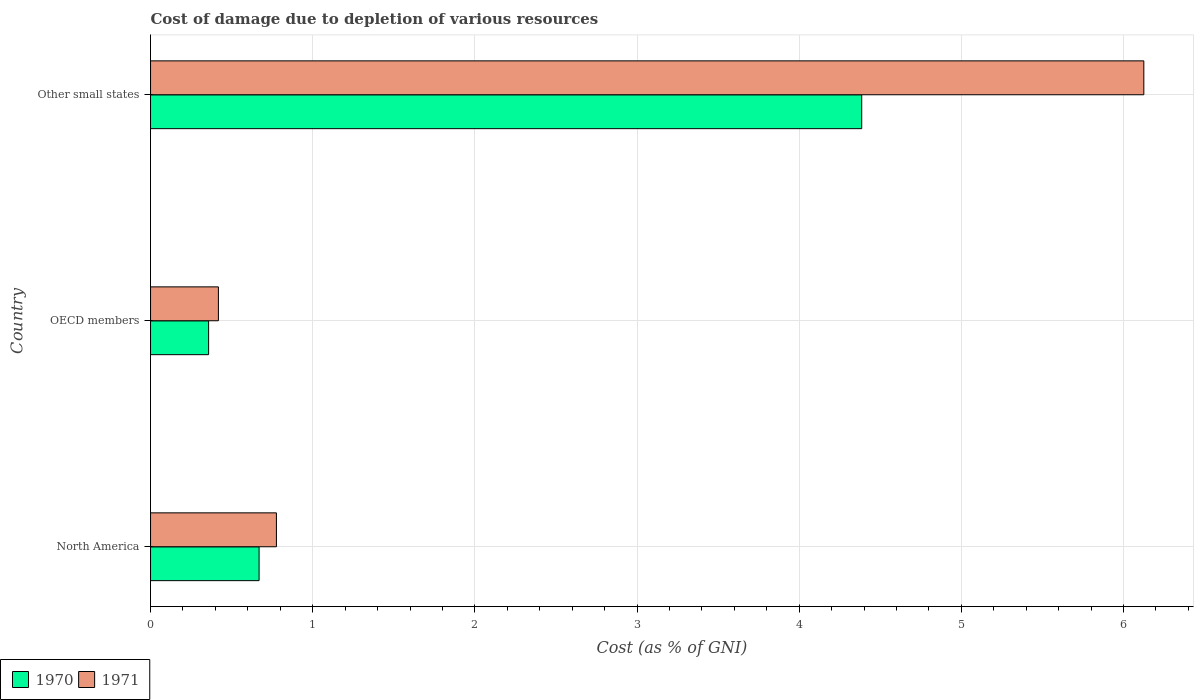How many different coloured bars are there?
Provide a succinct answer. 2. How many groups of bars are there?
Offer a very short reply. 3. Are the number of bars on each tick of the Y-axis equal?
Provide a short and direct response. Yes. How many bars are there on the 1st tick from the top?
Provide a succinct answer. 2. In how many cases, is the number of bars for a given country not equal to the number of legend labels?
Your response must be concise. 0. What is the cost of damage caused due to the depletion of various resources in 1970 in OECD members?
Give a very brief answer. 0.36. Across all countries, what is the maximum cost of damage caused due to the depletion of various resources in 1971?
Give a very brief answer. 6.13. Across all countries, what is the minimum cost of damage caused due to the depletion of various resources in 1971?
Make the answer very short. 0.42. In which country was the cost of damage caused due to the depletion of various resources in 1970 maximum?
Keep it short and to the point. Other small states. In which country was the cost of damage caused due to the depletion of various resources in 1971 minimum?
Provide a succinct answer. OECD members. What is the total cost of damage caused due to the depletion of various resources in 1971 in the graph?
Keep it short and to the point. 7.32. What is the difference between the cost of damage caused due to the depletion of various resources in 1970 in North America and that in OECD members?
Provide a short and direct response. 0.31. What is the difference between the cost of damage caused due to the depletion of various resources in 1971 in OECD members and the cost of damage caused due to the depletion of various resources in 1970 in Other small states?
Your response must be concise. -3.97. What is the average cost of damage caused due to the depletion of various resources in 1970 per country?
Offer a terse response. 1.8. What is the difference between the cost of damage caused due to the depletion of various resources in 1971 and cost of damage caused due to the depletion of various resources in 1970 in Other small states?
Your response must be concise. 1.74. In how many countries, is the cost of damage caused due to the depletion of various resources in 1971 greater than 6.2 %?
Provide a succinct answer. 0. What is the ratio of the cost of damage caused due to the depletion of various resources in 1970 in North America to that in Other small states?
Your response must be concise. 0.15. Is the cost of damage caused due to the depletion of various resources in 1971 in North America less than that in OECD members?
Provide a short and direct response. No. Is the difference between the cost of damage caused due to the depletion of various resources in 1971 in North America and OECD members greater than the difference between the cost of damage caused due to the depletion of various resources in 1970 in North America and OECD members?
Make the answer very short. Yes. What is the difference between the highest and the second highest cost of damage caused due to the depletion of various resources in 1971?
Your response must be concise. 5.35. What is the difference between the highest and the lowest cost of damage caused due to the depletion of various resources in 1971?
Ensure brevity in your answer.  5.71. In how many countries, is the cost of damage caused due to the depletion of various resources in 1971 greater than the average cost of damage caused due to the depletion of various resources in 1971 taken over all countries?
Provide a short and direct response. 1. What does the 2nd bar from the bottom in North America represents?
Ensure brevity in your answer.  1971. How many bars are there?
Make the answer very short. 6. How many countries are there in the graph?
Make the answer very short. 3. Are the values on the major ticks of X-axis written in scientific E-notation?
Provide a succinct answer. No. Does the graph contain grids?
Your answer should be very brief. Yes. How are the legend labels stacked?
Your answer should be compact. Horizontal. What is the title of the graph?
Keep it short and to the point. Cost of damage due to depletion of various resources. What is the label or title of the X-axis?
Keep it short and to the point. Cost (as % of GNI). What is the Cost (as % of GNI) in 1970 in North America?
Keep it short and to the point. 0.67. What is the Cost (as % of GNI) of 1971 in North America?
Your answer should be very brief. 0.78. What is the Cost (as % of GNI) of 1970 in OECD members?
Provide a succinct answer. 0.36. What is the Cost (as % of GNI) in 1971 in OECD members?
Give a very brief answer. 0.42. What is the Cost (as % of GNI) of 1970 in Other small states?
Your response must be concise. 4.39. What is the Cost (as % of GNI) in 1971 in Other small states?
Give a very brief answer. 6.13. Across all countries, what is the maximum Cost (as % of GNI) of 1970?
Offer a terse response. 4.39. Across all countries, what is the maximum Cost (as % of GNI) in 1971?
Your answer should be compact. 6.13. Across all countries, what is the minimum Cost (as % of GNI) in 1970?
Your response must be concise. 0.36. Across all countries, what is the minimum Cost (as % of GNI) of 1971?
Make the answer very short. 0.42. What is the total Cost (as % of GNI) in 1970 in the graph?
Offer a terse response. 5.41. What is the total Cost (as % of GNI) in 1971 in the graph?
Offer a terse response. 7.32. What is the difference between the Cost (as % of GNI) in 1970 in North America and that in OECD members?
Provide a succinct answer. 0.31. What is the difference between the Cost (as % of GNI) of 1971 in North America and that in OECD members?
Your answer should be compact. 0.36. What is the difference between the Cost (as % of GNI) in 1970 in North America and that in Other small states?
Offer a very short reply. -3.72. What is the difference between the Cost (as % of GNI) in 1971 in North America and that in Other small states?
Provide a short and direct response. -5.35. What is the difference between the Cost (as % of GNI) in 1970 in OECD members and that in Other small states?
Provide a short and direct response. -4.03. What is the difference between the Cost (as % of GNI) of 1971 in OECD members and that in Other small states?
Give a very brief answer. -5.71. What is the difference between the Cost (as % of GNI) of 1970 in North America and the Cost (as % of GNI) of 1971 in OECD members?
Offer a terse response. 0.25. What is the difference between the Cost (as % of GNI) of 1970 in North America and the Cost (as % of GNI) of 1971 in Other small states?
Keep it short and to the point. -5.46. What is the difference between the Cost (as % of GNI) in 1970 in OECD members and the Cost (as % of GNI) in 1971 in Other small states?
Your response must be concise. -5.77. What is the average Cost (as % of GNI) in 1970 per country?
Provide a short and direct response. 1.8. What is the average Cost (as % of GNI) of 1971 per country?
Keep it short and to the point. 2.44. What is the difference between the Cost (as % of GNI) of 1970 and Cost (as % of GNI) of 1971 in North America?
Make the answer very short. -0.11. What is the difference between the Cost (as % of GNI) of 1970 and Cost (as % of GNI) of 1971 in OECD members?
Your answer should be compact. -0.06. What is the difference between the Cost (as % of GNI) in 1970 and Cost (as % of GNI) in 1971 in Other small states?
Your answer should be very brief. -1.74. What is the ratio of the Cost (as % of GNI) of 1970 in North America to that in OECD members?
Keep it short and to the point. 1.87. What is the ratio of the Cost (as % of GNI) in 1971 in North America to that in OECD members?
Make the answer very short. 1.85. What is the ratio of the Cost (as % of GNI) in 1970 in North America to that in Other small states?
Your answer should be very brief. 0.15. What is the ratio of the Cost (as % of GNI) of 1971 in North America to that in Other small states?
Ensure brevity in your answer.  0.13. What is the ratio of the Cost (as % of GNI) of 1970 in OECD members to that in Other small states?
Ensure brevity in your answer.  0.08. What is the ratio of the Cost (as % of GNI) in 1971 in OECD members to that in Other small states?
Your response must be concise. 0.07. What is the difference between the highest and the second highest Cost (as % of GNI) of 1970?
Give a very brief answer. 3.72. What is the difference between the highest and the second highest Cost (as % of GNI) of 1971?
Ensure brevity in your answer.  5.35. What is the difference between the highest and the lowest Cost (as % of GNI) in 1970?
Your response must be concise. 4.03. What is the difference between the highest and the lowest Cost (as % of GNI) of 1971?
Your answer should be compact. 5.71. 